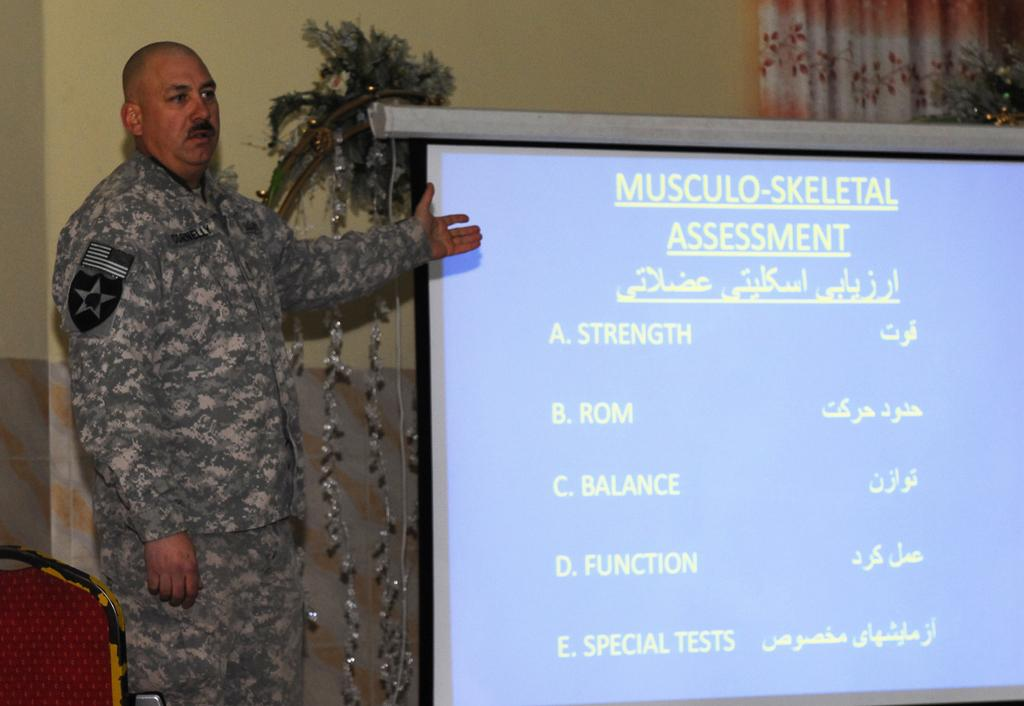What is the main subject in the image? There is a man standing in the image. What can be seen behind the man? There is a screen, a wall, a curtain, plants, and decorative objects in the background of the image. What is the man standing near? The man is standing near a chair in the image. What type of quill is the man using to write on the screen in the image? There is no quill present in the image, and the man is not writing on the screen. 